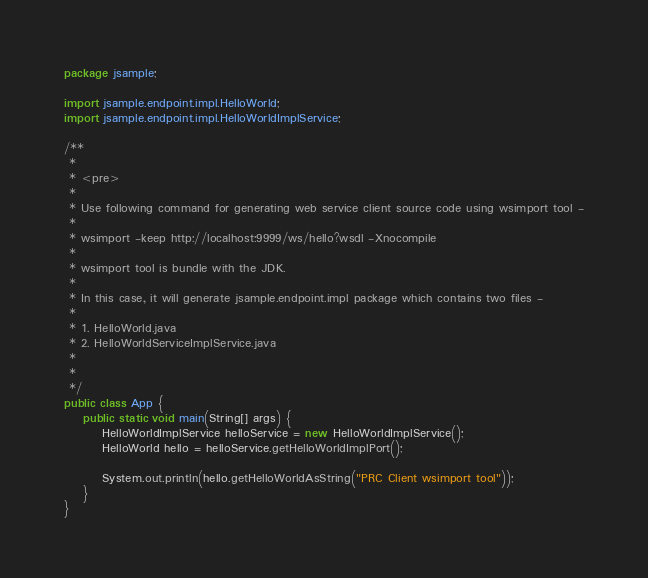Convert code to text. <code><loc_0><loc_0><loc_500><loc_500><_Java_>package jsample;

import jsample.endpoint.impl.HelloWorld;
import jsample.endpoint.impl.HelloWorldImplService;

/**
 * 
 * <pre>
 * 
 * Use following command for generating web service client source code using wsimport tool -
 * 
 * wsimport -keep http://localhost:9999/ws/hello?wsdl -Xnocompile
 * 
 * wsimport tool is bundle with the JDK.
 * 
 * In this case, it will generate jsample.endpoint.impl package which contains two files -
 * 
 * 1. HelloWorld.java
 * 2. HelloWorldServiceImplService.java
 * 
 * 
 */
public class App {
	public static void main(String[] args) {
		HelloWorldImplService helloService = new HelloWorldImplService();
		HelloWorld hello = helloService.getHelloWorldImplPort();

		System.out.println(hello.getHelloWorldAsString("PRC Client wsimport tool"));
	}
}
</code> 